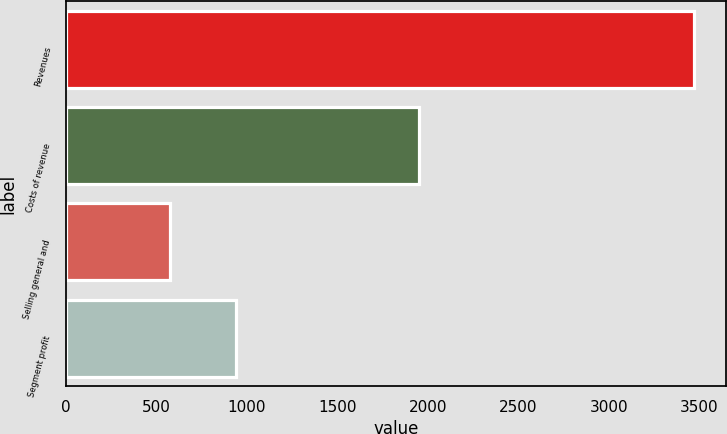<chart> <loc_0><loc_0><loc_500><loc_500><bar_chart><fcel>Revenues<fcel>Costs of revenue<fcel>Selling general and<fcel>Segment profit<nl><fcel>3472<fcel>1953<fcel>577<fcel>942<nl></chart> 